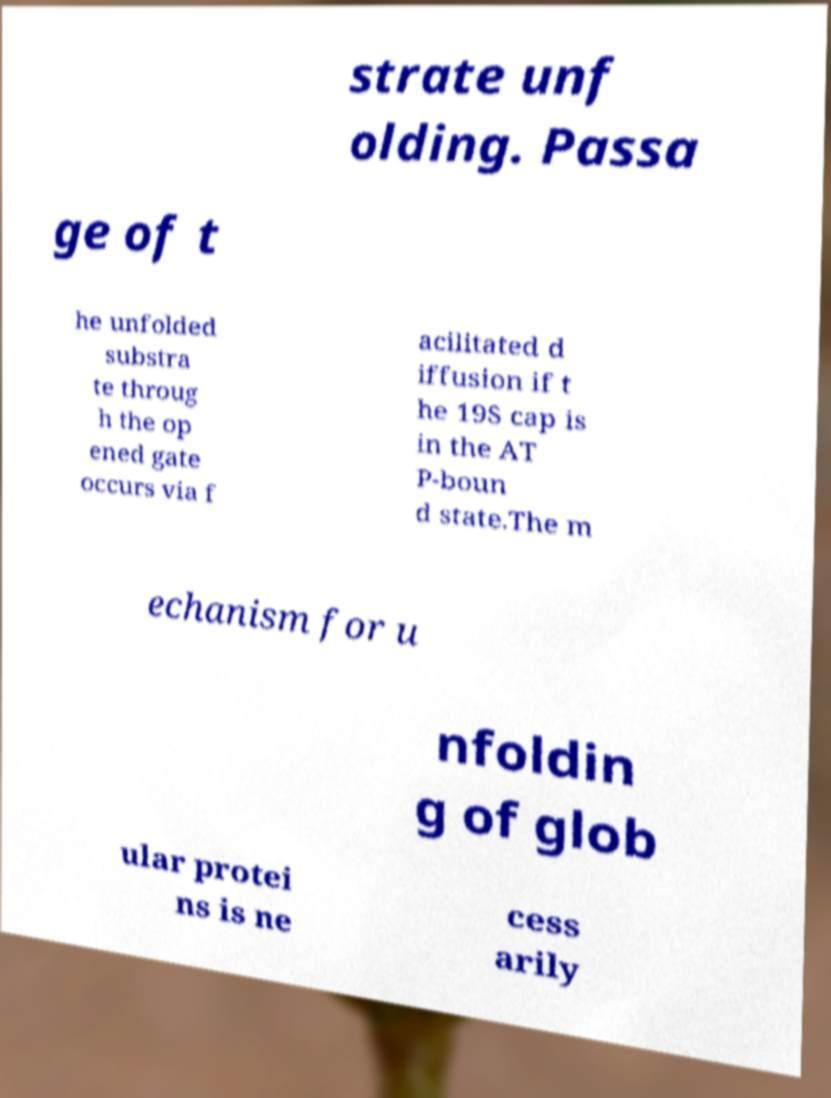Can you read and provide the text displayed in the image?This photo seems to have some interesting text. Can you extract and type it out for me? strate unf olding. Passa ge of t he unfolded substra te throug h the op ened gate occurs via f acilitated d iffusion if t he 19S cap is in the AT P-boun d state.The m echanism for u nfoldin g of glob ular protei ns is ne cess arily 